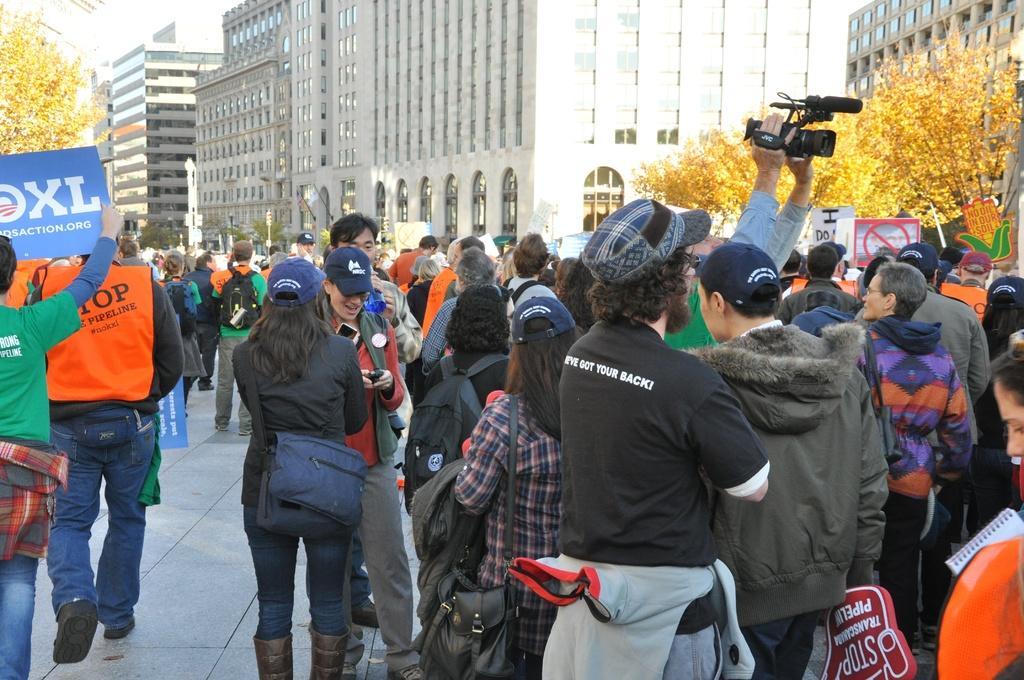Please provide a concise description of this image. The picture is taken outside a city. In the foreground of the picture there are people, placards, camera and other objects. On the right there are trees and buildings. On the left there are trees. In the center of the picture there are buildings and trees. 